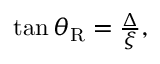<formula> <loc_0><loc_0><loc_500><loc_500>\begin{array} { r } { \tan \theta _ { R } = \frac { \Delta } { \xi } , } \end{array}</formula> 